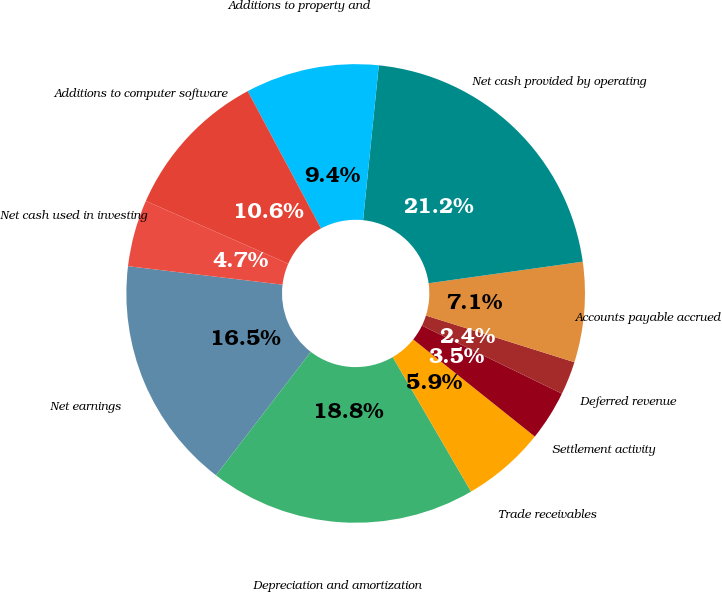Convert chart. <chart><loc_0><loc_0><loc_500><loc_500><pie_chart><fcel>Net earnings<fcel>Depreciation and amortization<fcel>Trade receivables<fcel>Settlement activity<fcel>Deferred revenue<fcel>Accounts payable accrued<fcel>Net cash provided by operating<fcel>Additions to property and<fcel>Additions to computer software<fcel>Net cash used in investing<nl><fcel>16.47%<fcel>18.82%<fcel>5.88%<fcel>3.53%<fcel>2.35%<fcel>7.06%<fcel>21.18%<fcel>9.41%<fcel>10.59%<fcel>4.71%<nl></chart> 